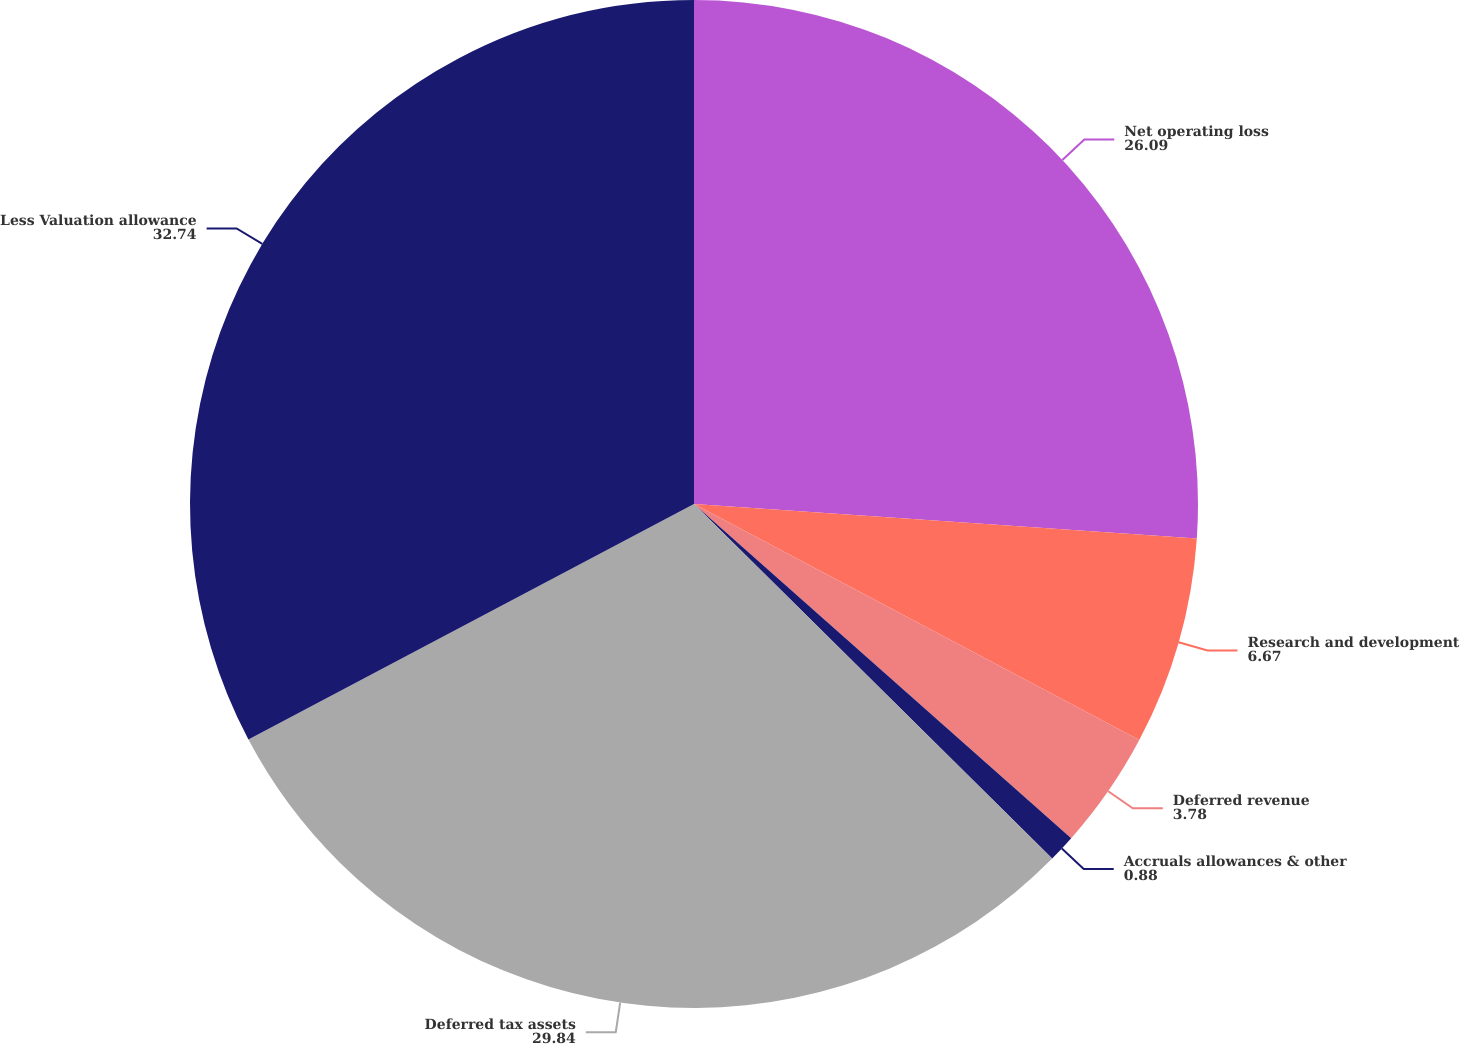<chart> <loc_0><loc_0><loc_500><loc_500><pie_chart><fcel>Net operating loss<fcel>Research and development<fcel>Deferred revenue<fcel>Accruals allowances & other<fcel>Deferred tax assets<fcel>Less Valuation allowance<nl><fcel>26.09%<fcel>6.67%<fcel>3.78%<fcel>0.88%<fcel>29.84%<fcel>32.74%<nl></chart> 